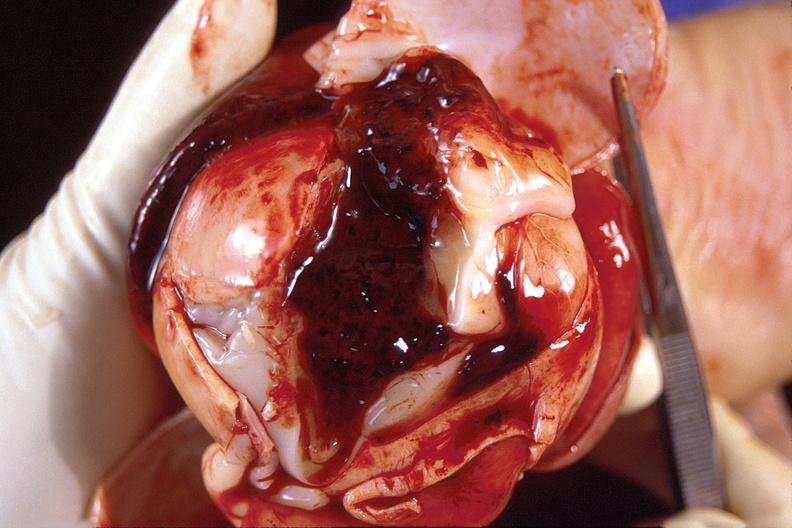what is present?
Answer the question using a single word or phrase. Nervous 